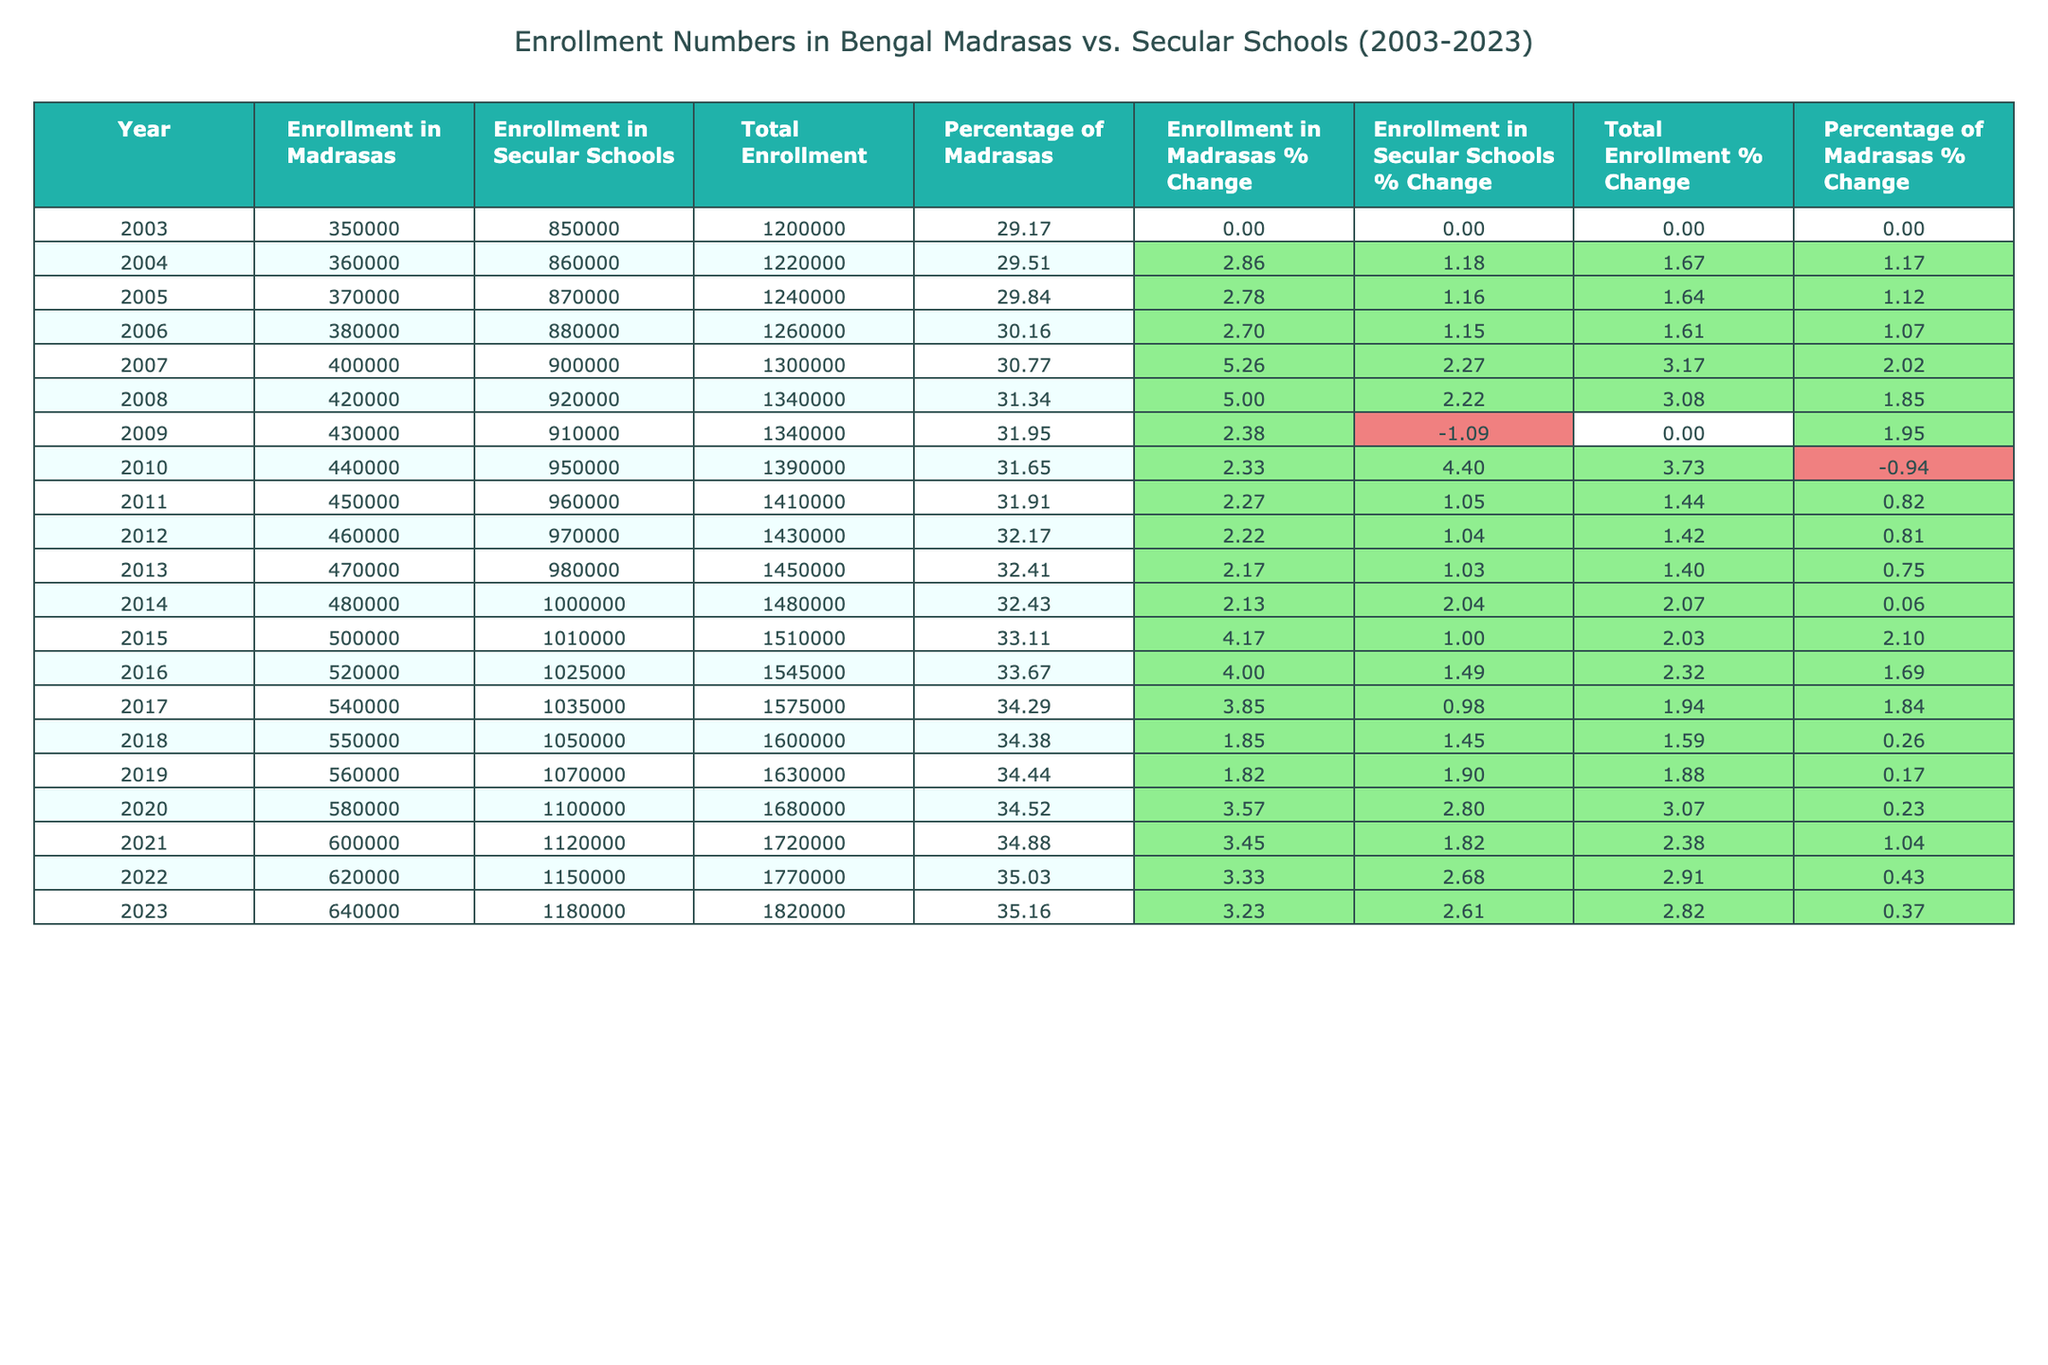What was the enrollment in Madrasas in 2010? The table shows that in the year 2010, the enrollment in Madrasas was 440,000.
Answer: 440,000 What was the total enrollment in 2023? According to the table, the total enrollment in 2023 was 1,820,000.
Answer: 1,820,000 Which year had the highest percentage of enrollment in Madrasas? By examining the percentage of Madrasas column, 2023 had the highest percentage at 35.16%.
Answer: 2023 What is the difference in enrollment between Madrasas in 2003 and 2023? In 2003, the enrollment was 350,000, and in 2023 it was 640,000. The difference is 640,000 - 350,000 = 290,000.
Answer: 290,000 What is the average enrollment in Secular Schools from 2003 to 2023? To find the average, sum the enrollment from the years provided, which totals 20,550,000, then divide by 21 (the number of years): 20,550,000 / 21 = 978,571.43. This can be rounded to 978,571.
Answer: 978,571 Is the percentage of Madrasas enrollment consistently increasing over the years? The percentage of Madrasas enrollment shows an overall increase from 29.17% in 2003 to 35.16% in 2023, demonstrating a consistent upward trend throughout the years.
Answer: Yes Which year saw the largest increase in enrollment in Madrasas? By examining the percent change between years, the largest increase occurred from 2014 to 2015, where the enrollment increased from 480,000 to 500,000, resulting in an approximate increase of 4.17%.
Answer: 2014 to 2015 In how many years did enrollment in Secular Schools exceed 1,000,000? Looking at the data, enrollment in Secular Schools exceeded 1,000,000 in the years 2015, 2016, 2017, 2018, 2019, 2020, 2021, 2022, and 2023, totaling 9 years.
Answer: 9 years What was the percentage change in Total Enrollment from 2010 to 2023? In 2010, total enrollment was 1,390,000, and in 2023 it was 1,820,000. The change is (1,820,000 - 1,390,000) / 1,390,000 * 100 = 30.95%.
Answer: 30.95% By how much did the enrollment in Madrasas increase in the years 2016 to 2018? In 2016, enrollment was 520,000, and in 2018 it was 550,000. The increase is 550,000 - 520,000 = 30,000.
Answer: 30,000 